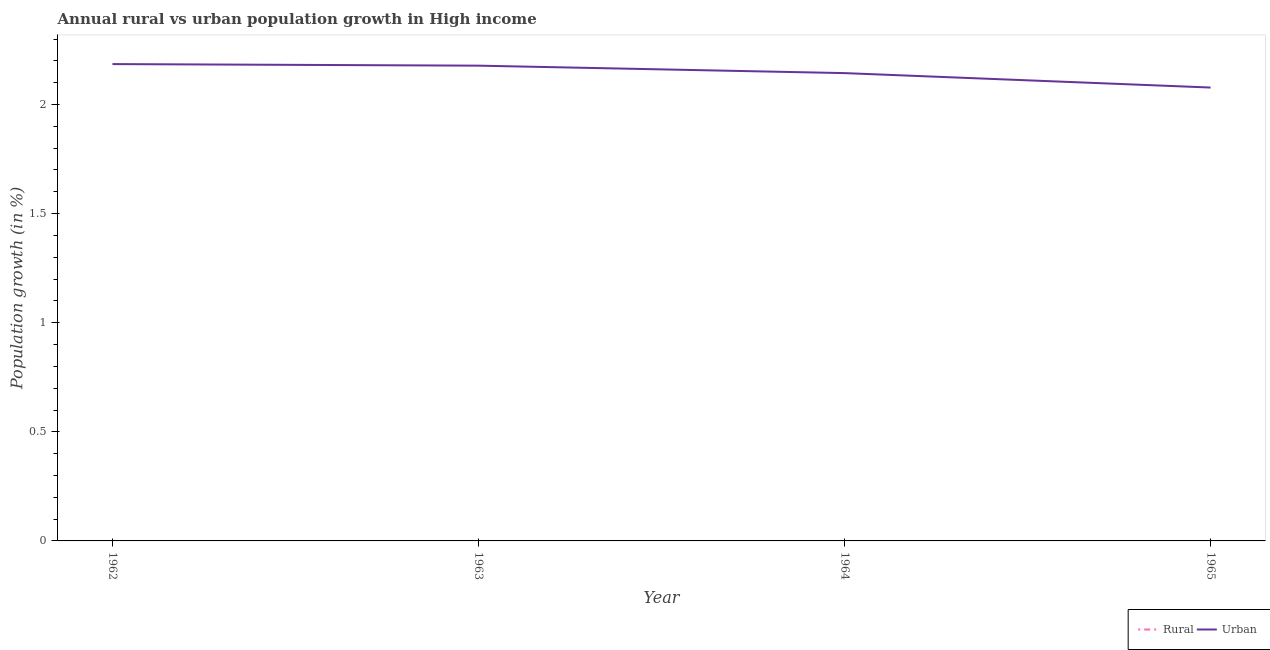Does the line corresponding to urban population growth intersect with the line corresponding to rural population growth?
Offer a terse response. No. What is the urban population growth in 1964?
Your response must be concise. 2.14. Across all years, what is the maximum urban population growth?
Your answer should be very brief. 2.19. Across all years, what is the minimum rural population growth?
Provide a succinct answer. 0. What is the total urban population growth in the graph?
Offer a terse response. 8.59. What is the difference between the urban population growth in 1962 and that in 1965?
Make the answer very short. 0.11. What is the difference between the urban population growth in 1964 and the rural population growth in 1965?
Your answer should be compact. 2.14. What is the average urban population growth per year?
Make the answer very short. 2.15. In how many years, is the rural population growth greater than 1.1 %?
Offer a terse response. 0. What is the ratio of the urban population growth in 1962 to that in 1964?
Provide a succinct answer. 1.02. What is the difference between the highest and the second highest urban population growth?
Your answer should be compact. 0.01. What is the difference between the highest and the lowest urban population growth?
Make the answer very short. 0.11. In how many years, is the urban population growth greater than the average urban population growth taken over all years?
Make the answer very short. 2. Is the sum of the urban population growth in 1962 and 1965 greater than the maximum rural population growth across all years?
Your answer should be compact. Yes. Does the urban population growth monotonically increase over the years?
Offer a terse response. No. Is the urban population growth strictly greater than the rural population growth over the years?
Make the answer very short. Yes. How many lines are there?
Your answer should be compact. 1. What is the difference between two consecutive major ticks on the Y-axis?
Provide a succinct answer. 0.5. Are the values on the major ticks of Y-axis written in scientific E-notation?
Ensure brevity in your answer.  No. Does the graph contain any zero values?
Offer a very short reply. Yes. Does the graph contain grids?
Give a very brief answer. No. How many legend labels are there?
Offer a very short reply. 2. What is the title of the graph?
Ensure brevity in your answer.  Annual rural vs urban population growth in High income. Does "All education staff compensation" appear as one of the legend labels in the graph?
Provide a succinct answer. No. What is the label or title of the X-axis?
Your response must be concise. Year. What is the label or title of the Y-axis?
Ensure brevity in your answer.  Population growth (in %). What is the Population growth (in %) in Rural in 1962?
Offer a very short reply. 0. What is the Population growth (in %) in Urban  in 1962?
Keep it short and to the point. 2.19. What is the Population growth (in %) of Urban  in 1963?
Ensure brevity in your answer.  2.18. What is the Population growth (in %) of Urban  in 1964?
Your response must be concise. 2.14. What is the Population growth (in %) in Rural in 1965?
Your answer should be very brief. 0. What is the Population growth (in %) of Urban  in 1965?
Keep it short and to the point. 2.08. Across all years, what is the maximum Population growth (in %) of Urban ?
Your response must be concise. 2.19. Across all years, what is the minimum Population growth (in %) in Urban ?
Offer a terse response. 2.08. What is the total Population growth (in %) in Rural in the graph?
Offer a terse response. 0. What is the total Population growth (in %) of Urban  in the graph?
Your response must be concise. 8.59. What is the difference between the Population growth (in %) of Urban  in 1962 and that in 1963?
Your answer should be very brief. 0.01. What is the difference between the Population growth (in %) of Urban  in 1962 and that in 1964?
Ensure brevity in your answer.  0.04. What is the difference between the Population growth (in %) in Urban  in 1962 and that in 1965?
Your answer should be very brief. 0.11. What is the difference between the Population growth (in %) in Urban  in 1963 and that in 1964?
Ensure brevity in your answer.  0.03. What is the difference between the Population growth (in %) of Urban  in 1963 and that in 1965?
Ensure brevity in your answer.  0.1. What is the difference between the Population growth (in %) of Urban  in 1964 and that in 1965?
Offer a very short reply. 0.07. What is the average Population growth (in %) of Urban  per year?
Provide a succinct answer. 2.15. What is the ratio of the Population growth (in %) in Urban  in 1962 to that in 1963?
Keep it short and to the point. 1. What is the ratio of the Population growth (in %) in Urban  in 1962 to that in 1964?
Keep it short and to the point. 1.02. What is the ratio of the Population growth (in %) of Urban  in 1962 to that in 1965?
Provide a succinct answer. 1.05. What is the ratio of the Population growth (in %) of Urban  in 1963 to that in 1964?
Provide a succinct answer. 1.02. What is the ratio of the Population growth (in %) of Urban  in 1963 to that in 1965?
Offer a very short reply. 1.05. What is the ratio of the Population growth (in %) of Urban  in 1964 to that in 1965?
Your response must be concise. 1.03. What is the difference between the highest and the second highest Population growth (in %) of Urban ?
Keep it short and to the point. 0.01. What is the difference between the highest and the lowest Population growth (in %) of Urban ?
Make the answer very short. 0.11. 